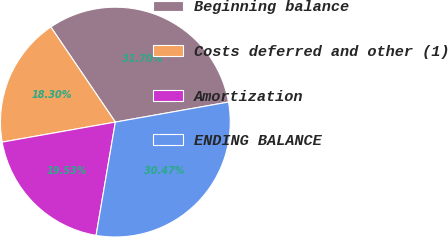Convert chart. <chart><loc_0><loc_0><loc_500><loc_500><pie_chart><fcel>Beginning balance<fcel>Costs deferred and other (1)<fcel>Amortization<fcel>ENDING BALANCE<nl><fcel>31.7%<fcel>18.3%<fcel>19.53%<fcel>30.47%<nl></chart> 